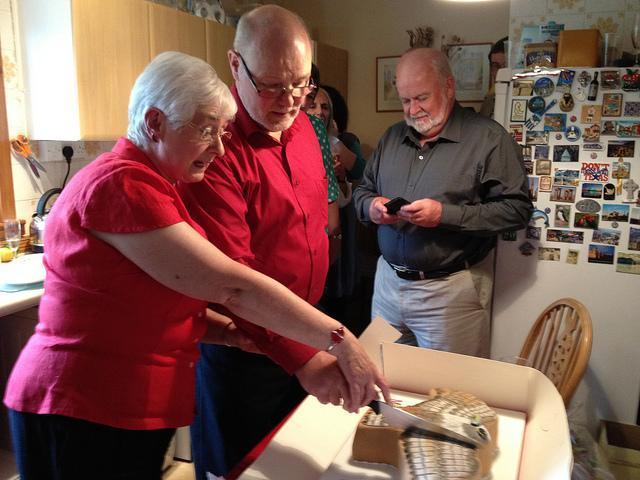How many people can you see?
Give a very brief answer. 3. 